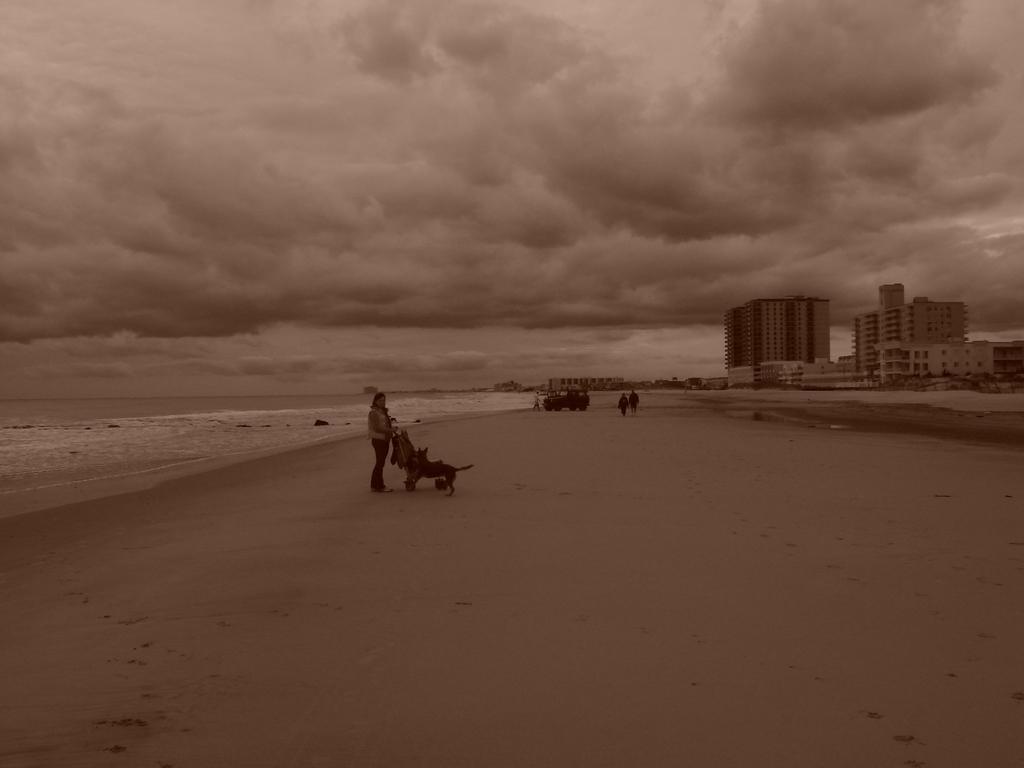Could you give a brief overview of what you see in this image? In the picture we can see a beach view with sand and some people standing on it and to the right hand side we can see some tower buildings and to the left hand side we can see water and in the background we can see the sky and clouds. 